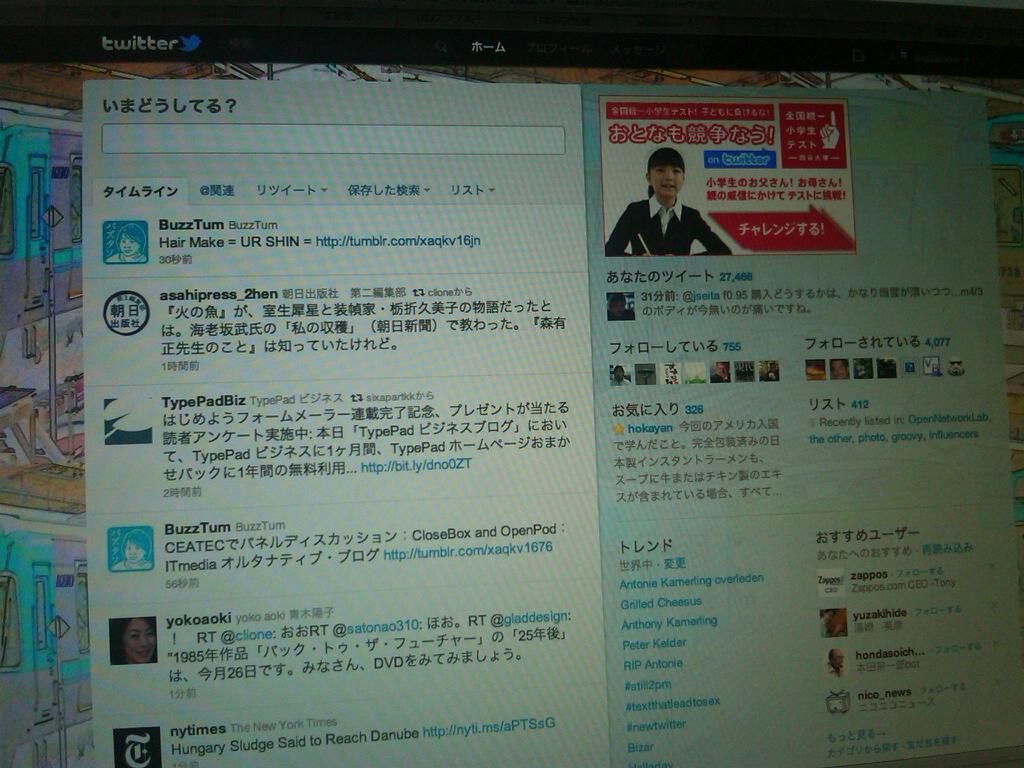<image>
Create a compact narrative representing the image presented. A twitter page shows one of the names in the bottom right is Grilled Cheesus. 